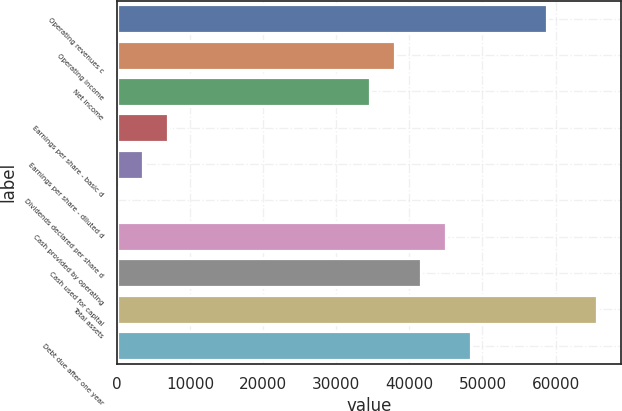Convert chart. <chart><loc_0><loc_0><loc_500><loc_500><bar_chart><fcel>Operating revenues c<fcel>Operating income<fcel>Net income<fcel>Earnings per share - basic d<fcel>Earnings per share - diluted d<fcel>Dividends declared per share d<fcel>Cash provided by operating<fcel>Cash used for capital<fcel>Total assets<fcel>Debt due after one year<nl><fcel>58812.8<fcel>38055.5<fcel>34596<fcel>6919.68<fcel>3460.14<fcel>0.6<fcel>44974.6<fcel>41515.1<fcel>65731.9<fcel>48434.2<nl></chart> 